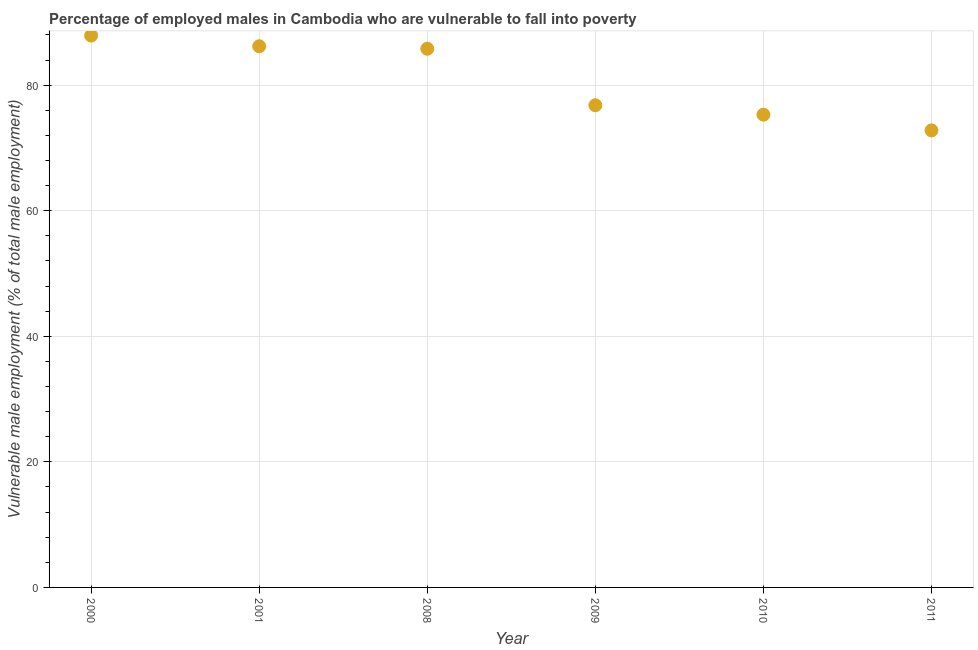What is the percentage of employed males who are vulnerable to fall into poverty in 2011?
Provide a short and direct response. 72.8. Across all years, what is the maximum percentage of employed males who are vulnerable to fall into poverty?
Your response must be concise. 87.9. Across all years, what is the minimum percentage of employed males who are vulnerable to fall into poverty?
Make the answer very short. 72.8. In which year was the percentage of employed males who are vulnerable to fall into poverty maximum?
Your answer should be very brief. 2000. What is the sum of the percentage of employed males who are vulnerable to fall into poverty?
Give a very brief answer. 484.8. What is the average percentage of employed males who are vulnerable to fall into poverty per year?
Your answer should be compact. 80.8. What is the median percentage of employed males who are vulnerable to fall into poverty?
Your answer should be compact. 81.3. Do a majority of the years between 2009 and 2000 (inclusive) have percentage of employed males who are vulnerable to fall into poverty greater than 20 %?
Provide a succinct answer. Yes. What is the ratio of the percentage of employed males who are vulnerable to fall into poverty in 2000 to that in 2011?
Offer a very short reply. 1.21. Is the percentage of employed males who are vulnerable to fall into poverty in 2008 less than that in 2010?
Offer a terse response. No. Is the difference between the percentage of employed males who are vulnerable to fall into poverty in 2001 and 2010 greater than the difference between any two years?
Offer a very short reply. No. What is the difference between the highest and the second highest percentage of employed males who are vulnerable to fall into poverty?
Keep it short and to the point. 1.7. Is the sum of the percentage of employed males who are vulnerable to fall into poverty in 2009 and 2011 greater than the maximum percentage of employed males who are vulnerable to fall into poverty across all years?
Keep it short and to the point. Yes. What is the difference between the highest and the lowest percentage of employed males who are vulnerable to fall into poverty?
Ensure brevity in your answer.  15.1. In how many years, is the percentage of employed males who are vulnerable to fall into poverty greater than the average percentage of employed males who are vulnerable to fall into poverty taken over all years?
Offer a very short reply. 3. Does the percentage of employed males who are vulnerable to fall into poverty monotonically increase over the years?
Keep it short and to the point. No. How many dotlines are there?
Your answer should be compact. 1. How many years are there in the graph?
Make the answer very short. 6. What is the difference between two consecutive major ticks on the Y-axis?
Your response must be concise. 20. Are the values on the major ticks of Y-axis written in scientific E-notation?
Keep it short and to the point. No. Does the graph contain any zero values?
Offer a terse response. No. What is the title of the graph?
Provide a succinct answer. Percentage of employed males in Cambodia who are vulnerable to fall into poverty. What is the label or title of the Y-axis?
Your response must be concise. Vulnerable male employment (% of total male employment). What is the Vulnerable male employment (% of total male employment) in 2000?
Your answer should be compact. 87.9. What is the Vulnerable male employment (% of total male employment) in 2001?
Provide a short and direct response. 86.2. What is the Vulnerable male employment (% of total male employment) in 2008?
Give a very brief answer. 85.8. What is the Vulnerable male employment (% of total male employment) in 2009?
Offer a terse response. 76.8. What is the Vulnerable male employment (% of total male employment) in 2010?
Your answer should be very brief. 75.3. What is the Vulnerable male employment (% of total male employment) in 2011?
Your answer should be compact. 72.8. What is the difference between the Vulnerable male employment (% of total male employment) in 2000 and 2011?
Offer a terse response. 15.1. What is the difference between the Vulnerable male employment (% of total male employment) in 2001 and 2008?
Keep it short and to the point. 0.4. What is the difference between the Vulnerable male employment (% of total male employment) in 2001 and 2009?
Your response must be concise. 9.4. What is the difference between the Vulnerable male employment (% of total male employment) in 2001 and 2010?
Provide a succinct answer. 10.9. What is the difference between the Vulnerable male employment (% of total male employment) in 2001 and 2011?
Offer a very short reply. 13.4. What is the difference between the Vulnerable male employment (% of total male employment) in 2008 and 2009?
Your answer should be compact. 9. What is the difference between the Vulnerable male employment (% of total male employment) in 2008 and 2010?
Make the answer very short. 10.5. What is the difference between the Vulnerable male employment (% of total male employment) in 2008 and 2011?
Offer a terse response. 13. What is the difference between the Vulnerable male employment (% of total male employment) in 2009 and 2010?
Keep it short and to the point. 1.5. What is the difference between the Vulnerable male employment (% of total male employment) in 2009 and 2011?
Your response must be concise. 4. What is the difference between the Vulnerable male employment (% of total male employment) in 2010 and 2011?
Your answer should be very brief. 2.5. What is the ratio of the Vulnerable male employment (% of total male employment) in 2000 to that in 2001?
Your answer should be very brief. 1.02. What is the ratio of the Vulnerable male employment (% of total male employment) in 2000 to that in 2009?
Keep it short and to the point. 1.15. What is the ratio of the Vulnerable male employment (% of total male employment) in 2000 to that in 2010?
Keep it short and to the point. 1.17. What is the ratio of the Vulnerable male employment (% of total male employment) in 2000 to that in 2011?
Ensure brevity in your answer.  1.21. What is the ratio of the Vulnerable male employment (% of total male employment) in 2001 to that in 2008?
Offer a terse response. 1. What is the ratio of the Vulnerable male employment (% of total male employment) in 2001 to that in 2009?
Keep it short and to the point. 1.12. What is the ratio of the Vulnerable male employment (% of total male employment) in 2001 to that in 2010?
Provide a short and direct response. 1.15. What is the ratio of the Vulnerable male employment (% of total male employment) in 2001 to that in 2011?
Keep it short and to the point. 1.18. What is the ratio of the Vulnerable male employment (% of total male employment) in 2008 to that in 2009?
Your answer should be compact. 1.12. What is the ratio of the Vulnerable male employment (% of total male employment) in 2008 to that in 2010?
Make the answer very short. 1.14. What is the ratio of the Vulnerable male employment (% of total male employment) in 2008 to that in 2011?
Provide a short and direct response. 1.18. What is the ratio of the Vulnerable male employment (% of total male employment) in 2009 to that in 2011?
Offer a terse response. 1.05. What is the ratio of the Vulnerable male employment (% of total male employment) in 2010 to that in 2011?
Your answer should be compact. 1.03. 